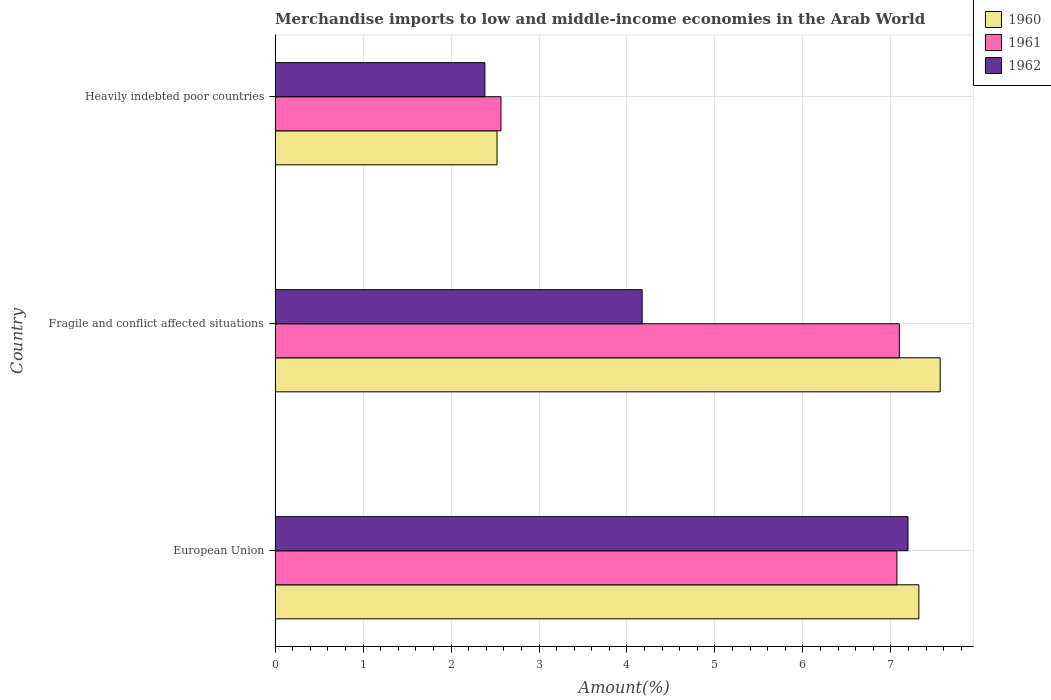Are the number of bars per tick equal to the number of legend labels?
Your response must be concise. Yes. Are the number of bars on each tick of the Y-axis equal?
Ensure brevity in your answer.  Yes. How many bars are there on the 3rd tick from the top?
Your answer should be very brief. 3. In how many cases, is the number of bars for a given country not equal to the number of legend labels?
Offer a terse response. 0. What is the percentage of amount earned from merchandise imports in 1962 in European Union?
Ensure brevity in your answer.  7.19. Across all countries, what is the maximum percentage of amount earned from merchandise imports in 1962?
Your answer should be very brief. 7.19. Across all countries, what is the minimum percentage of amount earned from merchandise imports in 1960?
Ensure brevity in your answer.  2.52. In which country was the percentage of amount earned from merchandise imports in 1960 maximum?
Offer a terse response. Fragile and conflict affected situations. In which country was the percentage of amount earned from merchandise imports in 1961 minimum?
Make the answer very short. Heavily indebted poor countries. What is the total percentage of amount earned from merchandise imports in 1962 in the graph?
Give a very brief answer. 13.75. What is the difference between the percentage of amount earned from merchandise imports in 1961 in Fragile and conflict affected situations and that in Heavily indebted poor countries?
Give a very brief answer. 4.53. What is the difference between the percentage of amount earned from merchandise imports in 1960 in Heavily indebted poor countries and the percentage of amount earned from merchandise imports in 1961 in European Union?
Keep it short and to the point. -4.55. What is the average percentage of amount earned from merchandise imports in 1961 per country?
Make the answer very short. 5.58. What is the difference between the percentage of amount earned from merchandise imports in 1962 and percentage of amount earned from merchandise imports in 1961 in Heavily indebted poor countries?
Provide a succinct answer. -0.18. In how many countries, is the percentage of amount earned from merchandise imports in 1962 greater than 3.2 %?
Give a very brief answer. 2. What is the ratio of the percentage of amount earned from merchandise imports in 1961 in European Union to that in Fragile and conflict affected situations?
Keep it short and to the point. 1. Is the percentage of amount earned from merchandise imports in 1960 in European Union less than that in Fragile and conflict affected situations?
Provide a succinct answer. Yes. What is the difference between the highest and the second highest percentage of amount earned from merchandise imports in 1961?
Ensure brevity in your answer.  0.03. What is the difference between the highest and the lowest percentage of amount earned from merchandise imports in 1961?
Your answer should be very brief. 4.53. In how many countries, is the percentage of amount earned from merchandise imports in 1962 greater than the average percentage of amount earned from merchandise imports in 1962 taken over all countries?
Your answer should be compact. 1. Is the sum of the percentage of amount earned from merchandise imports in 1961 in European Union and Fragile and conflict affected situations greater than the maximum percentage of amount earned from merchandise imports in 1960 across all countries?
Provide a short and direct response. Yes. What does the 1st bar from the top in European Union represents?
Provide a succinct answer. 1962. Is it the case that in every country, the sum of the percentage of amount earned from merchandise imports in 1960 and percentage of amount earned from merchandise imports in 1961 is greater than the percentage of amount earned from merchandise imports in 1962?
Provide a succinct answer. Yes. How many countries are there in the graph?
Offer a very short reply. 3. Does the graph contain any zero values?
Your response must be concise. No. How many legend labels are there?
Your answer should be very brief. 3. How are the legend labels stacked?
Provide a short and direct response. Vertical. What is the title of the graph?
Keep it short and to the point. Merchandise imports to low and middle-income economies in the Arab World. What is the label or title of the X-axis?
Your response must be concise. Amount(%). What is the label or title of the Y-axis?
Provide a short and direct response. Country. What is the Amount(%) of 1960 in European Union?
Offer a very short reply. 7.32. What is the Amount(%) of 1961 in European Union?
Your answer should be very brief. 7.07. What is the Amount(%) in 1962 in European Union?
Offer a terse response. 7.19. What is the Amount(%) in 1960 in Fragile and conflict affected situations?
Your answer should be very brief. 7.56. What is the Amount(%) in 1961 in Fragile and conflict affected situations?
Offer a terse response. 7.1. What is the Amount(%) in 1962 in Fragile and conflict affected situations?
Give a very brief answer. 4.17. What is the Amount(%) of 1960 in Heavily indebted poor countries?
Your answer should be very brief. 2.52. What is the Amount(%) in 1961 in Heavily indebted poor countries?
Ensure brevity in your answer.  2.57. What is the Amount(%) of 1962 in Heavily indebted poor countries?
Give a very brief answer. 2.38. Across all countries, what is the maximum Amount(%) in 1960?
Give a very brief answer. 7.56. Across all countries, what is the maximum Amount(%) in 1961?
Your answer should be very brief. 7.1. Across all countries, what is the maximum Amount(%) in 1962?
Make the answer very short. 7.19. Across all countries, what is the minimum Amount(%) in 1960?
Offer a very short reply. 2.52. Across all countries, what is the minimum Amount(%) in 1961?
Offer a terse response. 2.57. Across all countries, what is the minimum Amount(%) in 1962?
Provide a succinct answer. 2.38. What is the total Amount(%) in 1960 in the graph?
Make the answer very short. 17.4. What is the total Amount(%) of 1961 in the graph?
Your response must be concise. 16.73. What is the total Amount(%) of 1962 in the graph?
Offer a very short reply. 13.75. What is the difference between the Amount(%) in 1960 in European Union and that in Fragile and conflict affected situations?
Keep it short and to the point. -0.24. What is the difference between the Amount(%) in 1961 in European Union and that in Fragile and conflict affected situations?
Make the answer very short. -0.03. What is the difference between the Amount(%) of 1962 in European Union and that in Fragile and conflict affected situations?
Your answer should be compact. 3.02. What is the difference between the Amount(%) of 1960 in European Union and that in Heavily indebted poor countries?
Provide a short and direct response. 4.79. What is the difference between the Amount(%) of 1961 in European Union and that in Heavily indebted poor countries?
Give a very brief answer. 4.5. What is the difference between the Amount(%) of 1962 in European Union and that in Heavily indebted poor countries?
Provide a succinct answer. 4.81. What is the difference between the Amount(%) of 1960 in Fragile and conflict affected situations and that in Heavily indebted poor countries?
Give a very brief answer. 5.04. What is the difference between the Amount(%) in 1961 in Fragile and conflict affected situations and that in Heavily indebted poor countries?
Offer a terse response. 4.53. What is the difference between the Amount(%) of 1962 in Fragile and conflict affected situations and that in Heavily indebted poor countries?
Make the answer very short. 1.79. What is the difference between the Amount(%) of 1960 in European Union and the Amount(%) of 1961 in Fragile and conflict affected situations?
Give a very brief answer. 0.22. What is the difference between the Amount(%) of 1960 in European Union and the Amount(%) of 1962 in Fragile and conflict affected situations?
Keep it short and to the point. 3.15. What is the difference between the Amount(%) in 1961 in European Union and the Amount(%) in 1962 in Fragile and conflict affected situations?
Provide a succinct answer. 2.9. What is the difference between the Amount(%) in 1960 in European Union and the Amount(%) in 1961 in Heavily indebted poor countries?
Offer a very short reply. 4.75. What is the difference between the Amount(%) in 1960 in European Union and the Amount(%) in 1962 in Heavily indebted poor countries?
Your answer should be compact. 4.93. What is the difference between the Amount(%) in 1961 in European Union and the Amount(%) in 1962 in Heavily indebted poor countries?
Your response must be concise. 4.68. What is the difference between the Amount(%) of 1960 in Fragile and conflict affected situations and the Amount(%) of 1961 in Heavily indebted poor countries?
Your answer should be compact. 4.99. What is the difference between the Amount(%) in 1960 in Fragile and conflict affected situations and the Amount(%) in 1962 in Heavily indebted poor countries?
Provide a short and direct response. 5.18. What is the difference between the Amount(%) of 1961 in Fragile and conflict affected situations and the Amount(%) of 1962 in Heavily indebted poor countries?
Provide a short and direct response. 4.71. What is the average Amount(%) in 1960 per country?
Provide a short and direct response. 5.8. What is the average Amount(%) in 1961 per country?
Provide a succinct answer. 5.58. What is the average Amount(%) of 1962 per country?
Ensure brevity in your answer.  4.58. What is the difference between the Amount(%) of 1960 and Amount(%) of 1961 in European Union?
Your answer should be very brief. 0.25. What is the difference between the Amount(%) of 1960 and Amount(%) of 1962 in European Union?
Keep it short and to the point. 0.12. What is the difference between the Amount(%) in 1961 and Amount(%) in 1962 in European Union?
Make the answer very short. -0.13. What is the difference between the Amount(%) of 1960 and Amount(%) of 1961 in Fragile and conflict affected situations?
Make the answer very short. 0.46. What is the difference between the Amount(%) in 1960 and Amount(%) in 1962 in Fragile and conflict affected situations?
Make the answer very short. 3.39. What is the difference between the Amount(%) in 1961 and Amount(%) in 1962 in Fragile and conflict affected situations?
Make the answer very short. 2.92. What is the difference between the Amount(%) of 1960 and Amount(%) of 1961 in Heavily indebted poor countries?
Offer a very short reply. -0.04. What is the difference between the Amount(%) in 1960 and Amount(%) in 1962 in Heavily indebted poor countries?
Your response must be concise. 0.14. What is the difference between the Amount(%) in 1961 and Amount(%) in 1962 in Heavily indebted poor countries?
Your answer should be compact. 0.18. What is the ratio of the Amount(%) in 1960 in European Union to that in Fragile and conflict affected situations?
Offer a very short reply. 0.97. What is the ratio of the Amount(%) in 1962 in European Union to that in Fragile and conflict affected situations?
Make the answer very short. 1.72. What is the ratio of the Amount(%) of 1960 in European Union to that in Heavily indebted poor countries?
Your response must be concise. 2.9. What is the ratio of the Amount(%) of 1961 in European Union to that in Heavily indebted poor countries?
Provide a short and direct response. 2.75. What is the ratio of the Amount(%) in 1962 in European Union to that in Heavily indebted poor countries?
Provide a succinct answer. 3.02. What is the ratio of the Amount(%) of 1960 in Fragile and conflict affected situations to that in Heavily indebted poor countries?
Your answer should be compact. 3. What is the ratio of the Amount(%) of 1961 in Fragile and conflict affected situations to that in Heavily indebted poor countries?
Make the answer very short. 2.76. What is the ratio of the Amount(%) of 1962 in Fragile and conflict affected situations to that in Heavily indebted poor countries?
Your answer should be very brief. 1.75. What is the difference between the highest and the second highest Amount(%) in 1960?
Your answer should be very brief. 0.24. What is the difference between the highest and the second highest Amount(%) in 1961?
Offer a terse response. 0.03. What is the difference between the highest and the second highest Amount(%) of 1962?
Make the answer very short. 3.02. What is the difference between the highest and the lowest Amount(%) of 1960?
Keep it short and to the point. 5.04. What is the difference between the highest and the lowest Amount(%) of 1961?
Provide a short and direct response. 4.53. What is the difference between the highest and the lowest Amount(%) in 1962?
Your response must be concise. 4.81. 